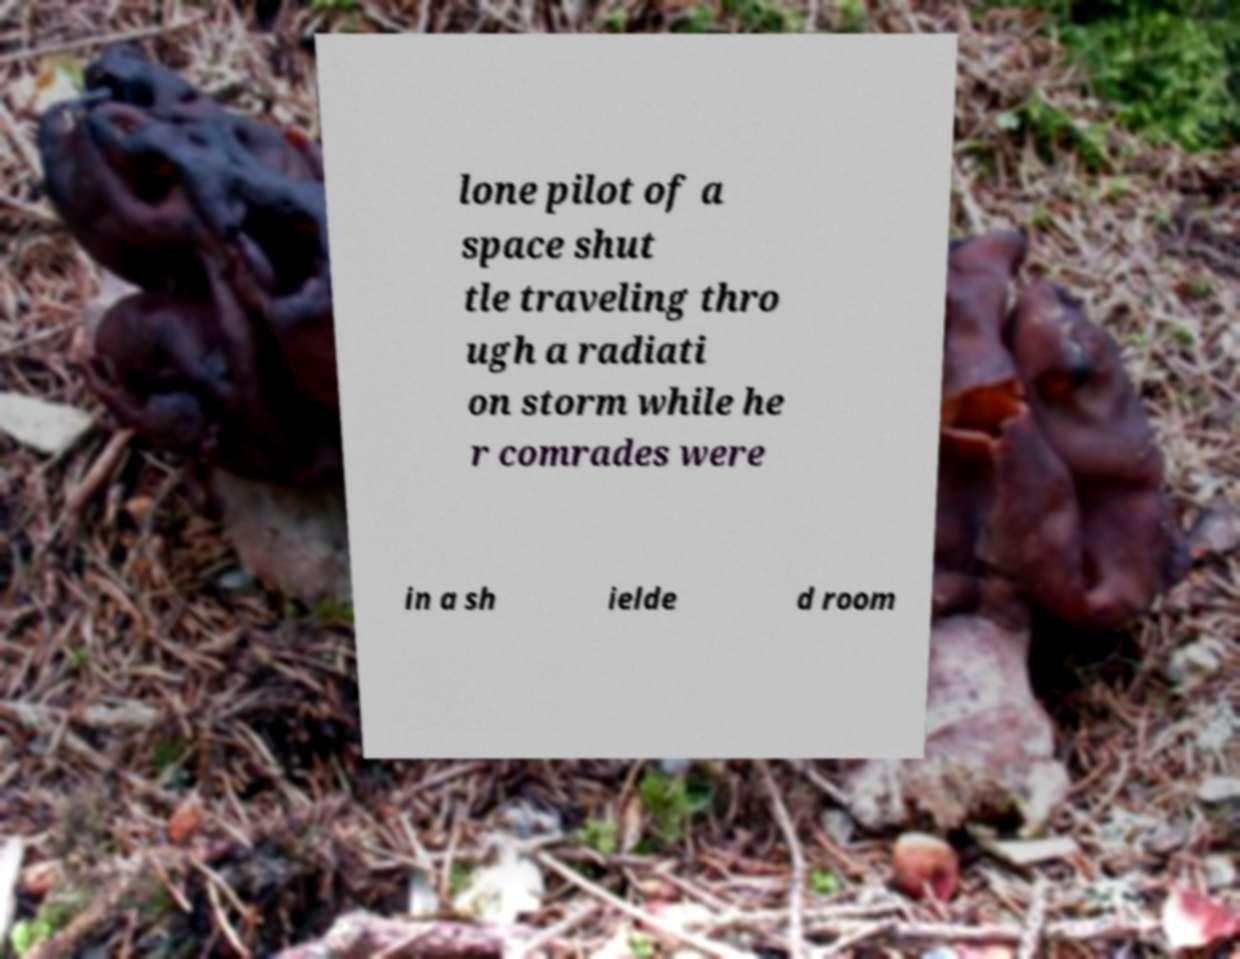I need the written content from this picture converted into text. Can you do that? lone pilot of a space shut tle traveling thro ugh a radiati on storm while he r comrades were in a sh ielde d room 